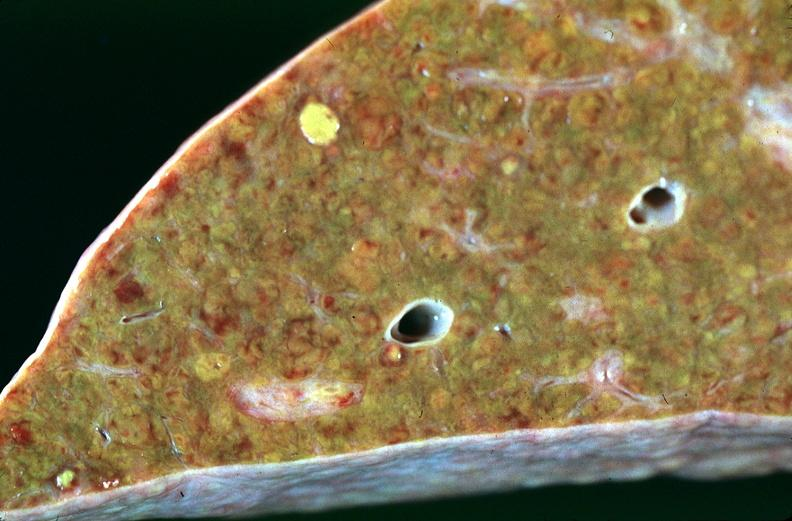what does this image show?
Answer the question using a single word or phrase. Liver 